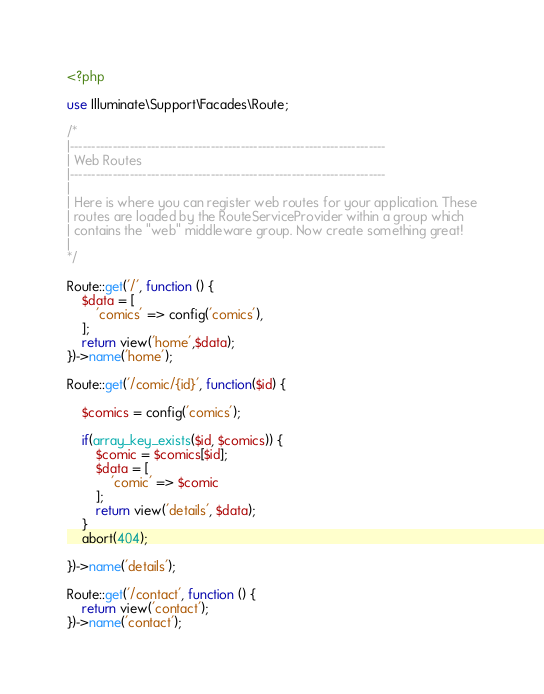Convert code to text. <code><loc_0><loc_0><loc_500><loc_500><_PHP_><?php

use Illuminate\Support\Facades\Route;

/*
|--------------------------------------------------------------------------
| Web Routes
|--------------------------------------------------------------------------
|
| Here is where you can register web routes for your application. These
| routes are loaded by the RouteServiceProvider within a group which
| contains the "web" middleware group. Now create something great!
|
*/

Route::get('/', function () {
    $data = [
        'comics' => config('comics'),
    ];
    return view('home',$data);
})->name('home');

Route::get('/comic/{id}', function($id) {

    $comics = config('comics');

    if(array_key_exists($id, $comics)) {
        $comic = $comics[$id];
        $data = [
            'comic' => $comic
        ];
        return view('details', $data);
    }
    abort(404);
    
})->name('details');

Route::get('/contact', function () {
    return view('contact');
})->name('contact');
</code> 